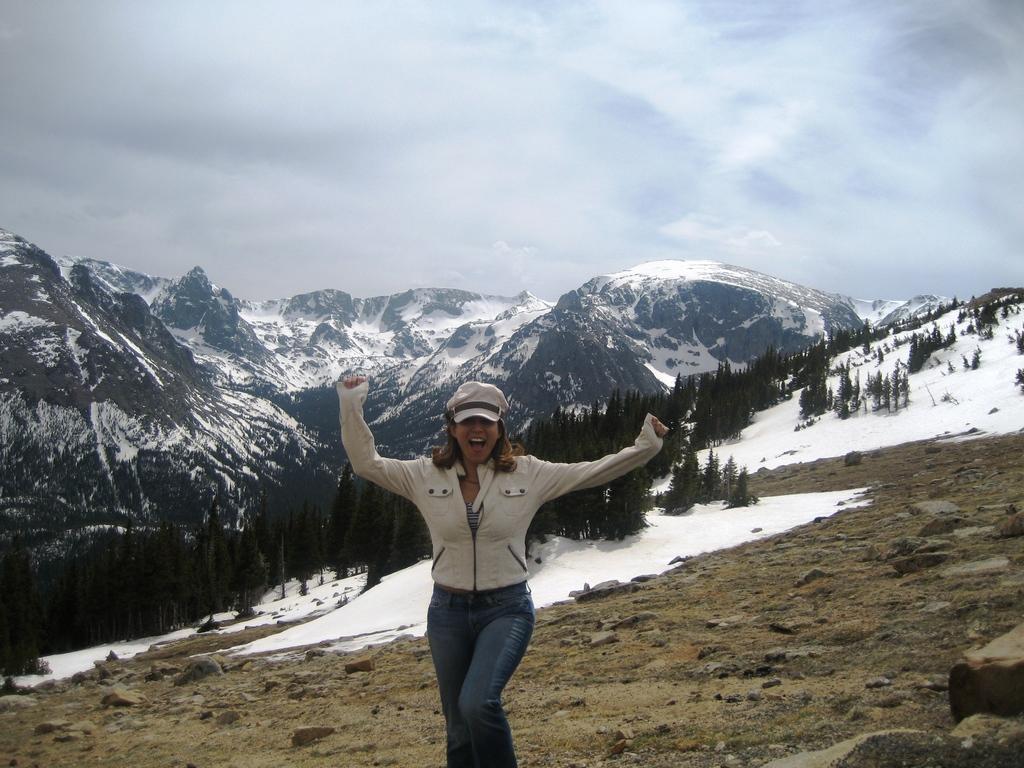How would you summarize this image in a sentence or two? In this image there are mountains. There are trees and grass. There is fog. There is a woman. There are clouds in the sky. 